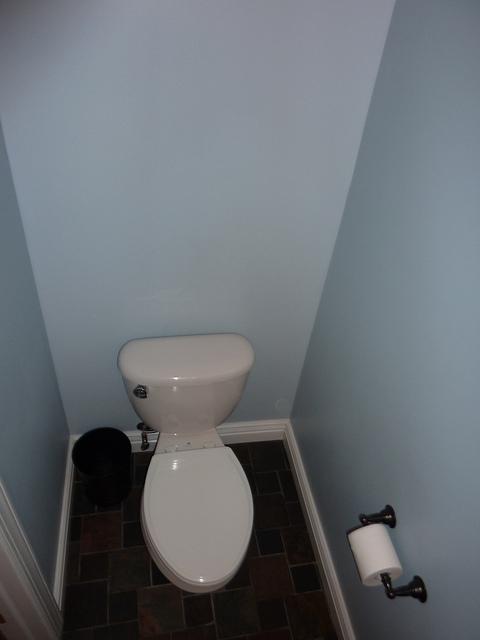Is the toilet paper hung overhand or underhand?
Keep it brief. Overhand. Does this person like to decorate?
Be succinct. No. What color are the walls?
Give a very brief answer. Blue. Is this a great bathroom?
Give a very brief answer. No. How many rolls of toilet paper are in the picture?
Answer briefly. 1. Is the toilet paper roll brand new?
Quick response, please. No. See any magazines?
Be succinct. No. Is the lid up?
Write a very short answer. No. Is the room big or small?
Write a very short answer. Small. Is the wall one color?
Concise answer only. Yes. Does this bathroom have a lot of detail?
Concise answer only. No. Is this a regular toilet?
Short answer required. Yes. Is the toilet seat a different color than the toilet?
Give a very brief answer. No. What color is the floor?
Give a very brief answer. Brown. Is this a clean restroom?
Concise answer only. Yes. Is there a rug on the floor?
Concise answer only. No. What is hanging on the wall?
Give a very brief answer. Toilet paper. Is the toilet seat up or down?
Quick response, please. Down. Are there pictures on the wall?
Short answer required. No. What color is are the dark tiles?
Short answer required. Black. Is that a plant?
Be succinct. No. Does this toilet work?
Concise answer only. Yes. Is this a vase?
Concise answer only. No. 